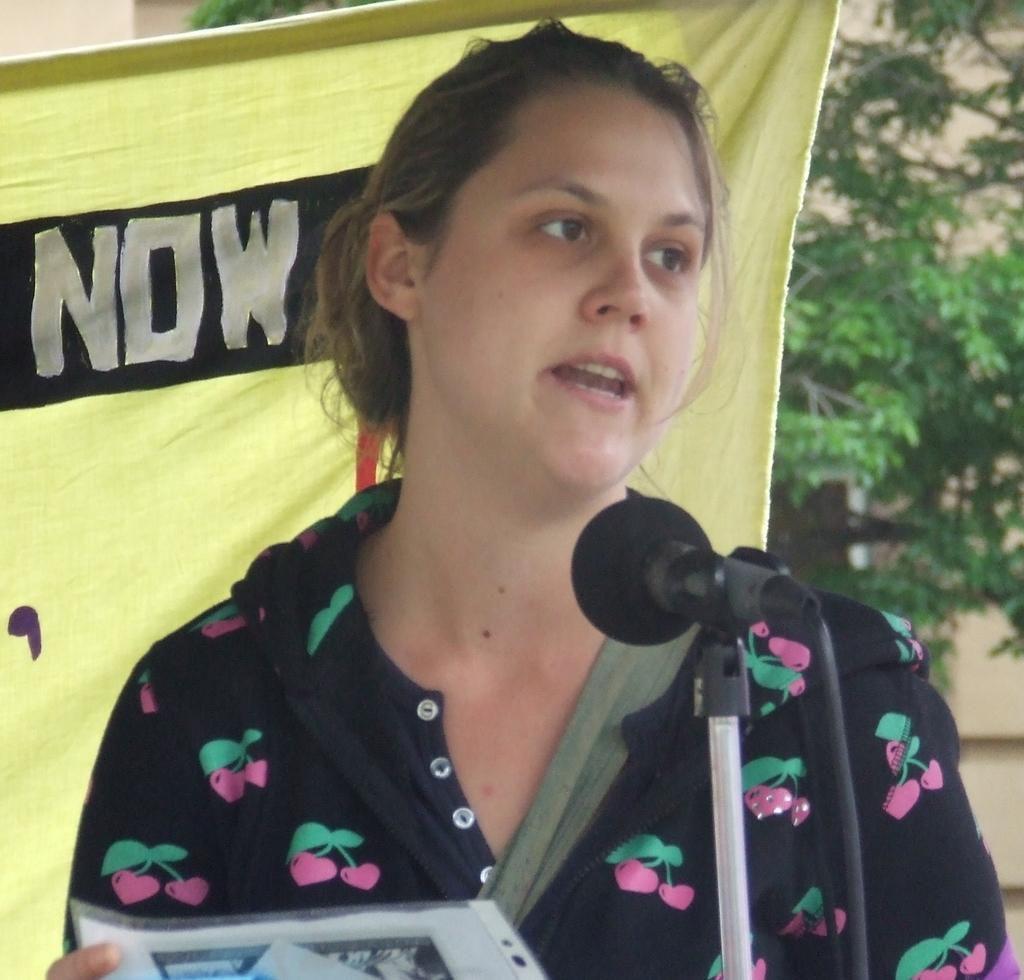Who is present in the image? There is a woman in the image. What is the woman holding? The woman is holding a paper. What object is in front of the woman? There is a microphone with a stand in front of the woman. What can be seen behind the woman? There is a banner behind the woman. What type of natural environment is visible in the background? Trees are visible in the background of the image. What type of quiver can be seen on the woman's back in the image? There is no quiver present on the woman's back in the image. What type of hospital is visible in the background of the image? There is no hospital visible in the background of the image; only trees are present. 